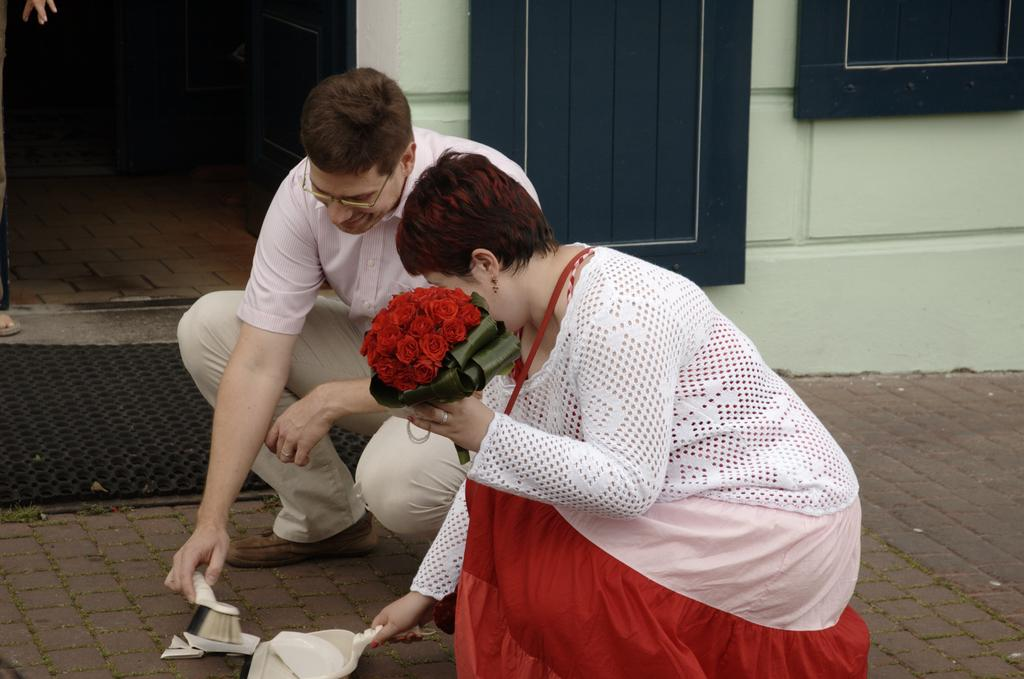What is the man in the image holding? The man is holding a brush. What is the woman in the image holding? The woman is holding a bouquet. How are the man and woman positioned in the image? Both the man and woman are sitting on their knees on the footpath. What can be seen in the background of the image? There is a rubber mat, a wall, and a door in the background of a building in the background of the image. What type of berry is being cooked on the stove in the image? There is no stove or berry present in the image. What kind of board is being used by the man and woman in the image? There is no board visible in the image; the man is holding a brush, and the woman is holding a bouquet. 